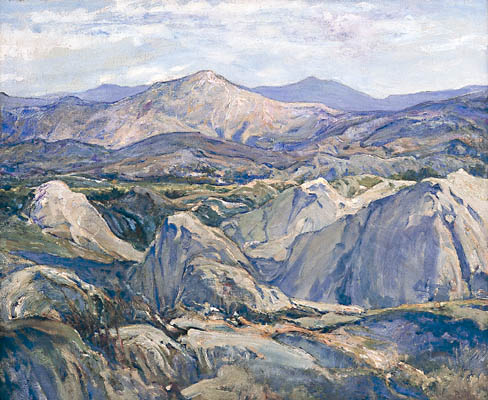Imagine you are walking through the landscape portrayed in the image. Describe your journey in detail. As I walk through the landscape, the first thing I notice is the crisp, fresh air filling my lungs. The towering mountains in the distance seem to watch over me like ancient guardians. The path beneath my feet is uneven, with scattered stones and patches of wild grass. I step carefully, feeling the texture of the earth change with every step.

The colors around me are vibrant yet calming. The blue-green hues of the hills contrast beautifully with the muted grays and purples of the mountains. As I walk further, I come across a gentle stream, its water clear and cold. The soft rush of the water is soothing, blending harmoniously with the gentle rustling of the trees in the wind.

Birds chirp occasionally, their calls echoing in the vast expanse. There is a profound silence that envelops the landscape, broken only by the sounds of nature. It's a place where time seems to stand still, allowing me to lose myself in the sheer beauty of the natural world around me. As the day progresses, how does the changing light affect your perception of the landscape? As the sun begins its descent, the landscape undergoes a mesmerizing transformation. The golden light of late afternoon casts long, soft shadows over the valleys and hills. The once-cool blues and greens warm into richer, more vibrant tones. The mountains, draped in hues of purple and orange, appear almost ethereal, as if bathed in a divine glow.

Every rock and leaf seems to shimmer with an inner light, and the air takes on a magical, almost mystical quality. The changing light brings out details that were hidden before, revealing new layers of beauty. The tranquility of the scene is deepened by the warm glow, and I feel an overwhelming sense of peace and contentment as I continue my journey through this breathtaking landscape. 